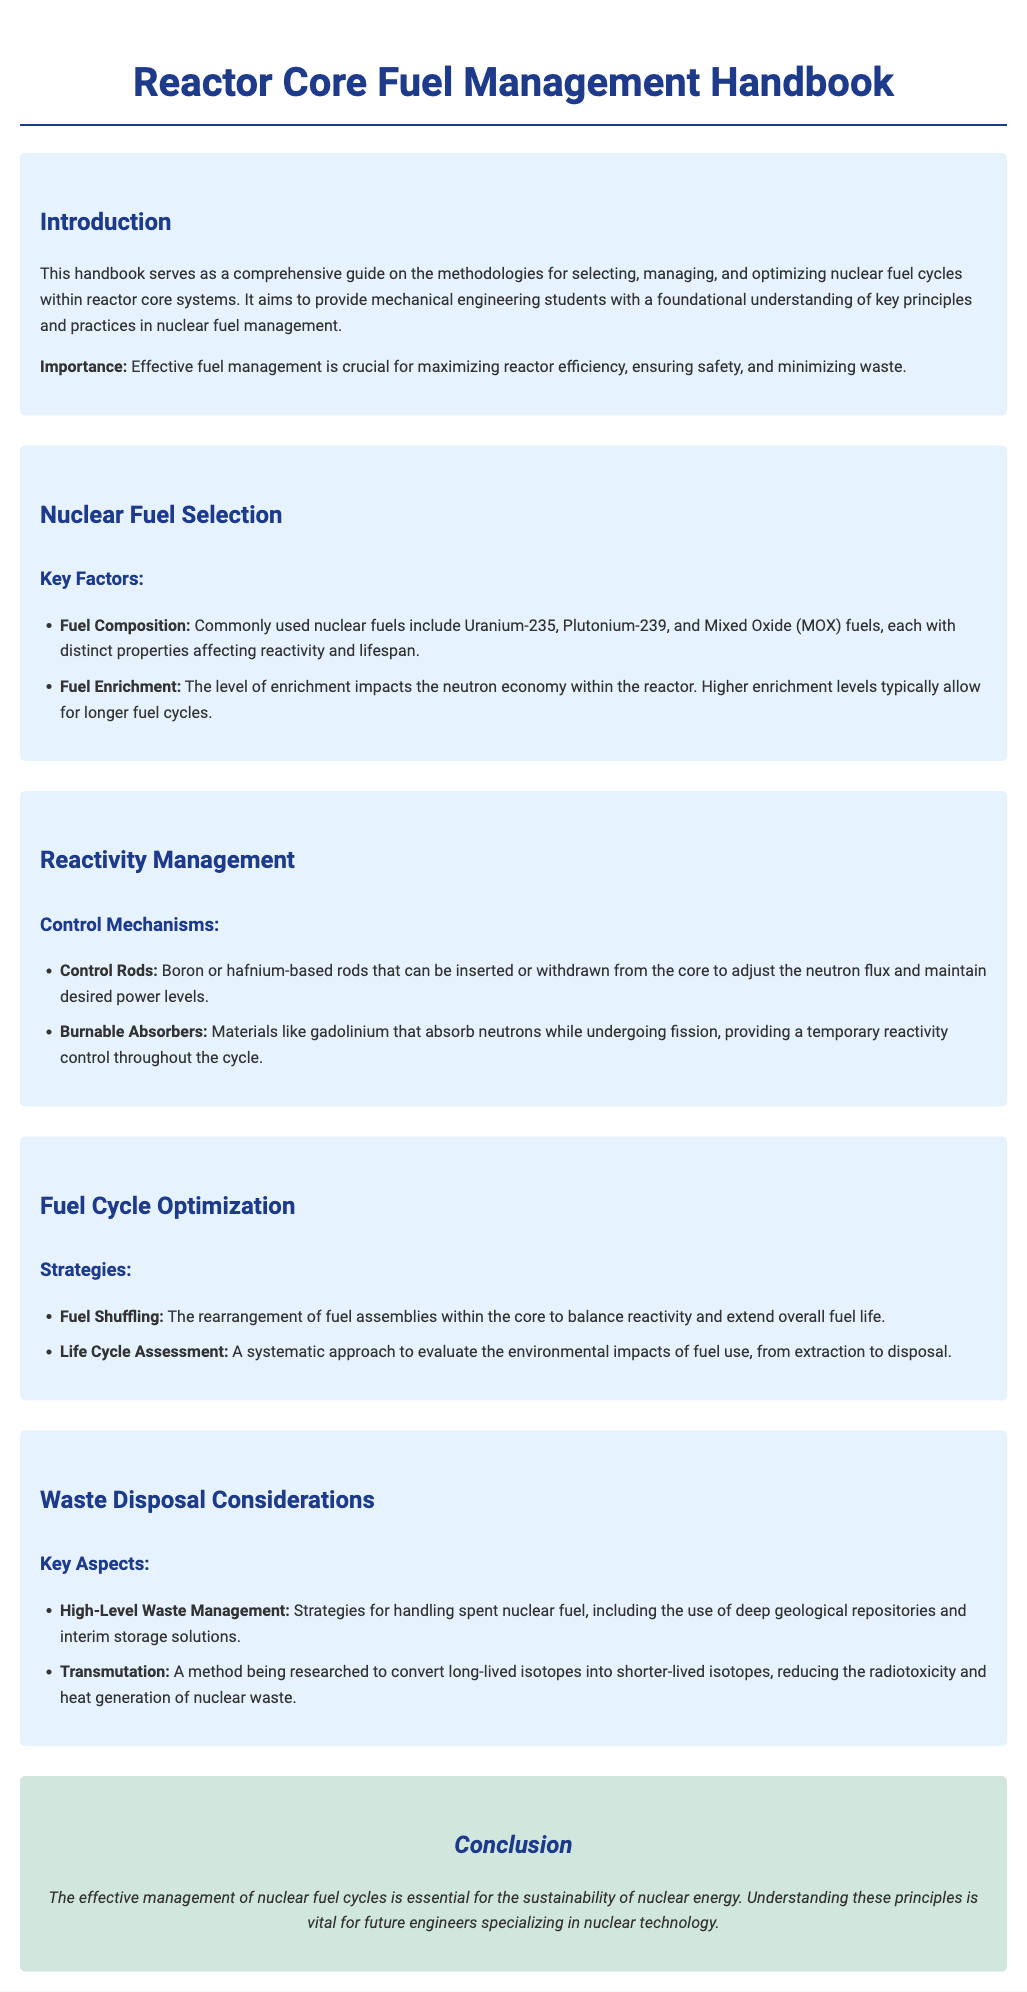What is the primary purpose of the handbook? The introduction states that the handbook serves as a comprehensive guide on the methodologies for selecting, managing, and optimizing nuclear fuel cycles within reactor core systems.
Answer: Comprehensive guide on methodologies What are the commonly used nuclear fuels mentioned? The document lists Uranium-235, Plutonium-239, and Mixed Oxide (MOX) fuels as commonly used nuclear fuels.
Answer: Uranium-235, Plutonium-239, and Mixed Oxide (MOX) fuels What is the role of control rods? The section on reactivity management describes control rods as boron or hafnium-based rods that can be inserted or withdrawn to adjust neutron flux.
Answer: Adjust neutron flux What is one strategy for fuel cycle optimization? The document mentions fuel shuffling as a strategy for rearranging fuel assemblies to balance reactivity and extend fuel life.
Answer: Fuel shuffling What does transmutation aim to reduce? The waste disposal considerations indicate that transmutation aims to reduce the radiotoxicity and heat generation of nuclear waste.
Answer: Radiotoxicity and heat generation What is highlighted as crucial for effective fuel management? The introduction emphasizes that effective fuel management is crucial for maximizing reactor efficiency, ensuring safety, and minimizing waste.
Answer: Maximizing reactor efficiency What type of waste management strategy is described for spent nuclear fuel? High-Level Waste Management describes strategies such as deep geological repositories and interim storage solutions.
Answer: Deep geological repositories What is the importance of fuel enrichment? The document states that the level of enrichment impacts the neutron economy within the reactor, allowing for longer fuel cycles.
Answer: Impacts neutron economy What overarching theme is concluded in this handbook? The conclusion states that effective management of nuclear fuel cycles is essential for the sustainability of nuclear energy.
Answer: Sustainability of nuclear energy 